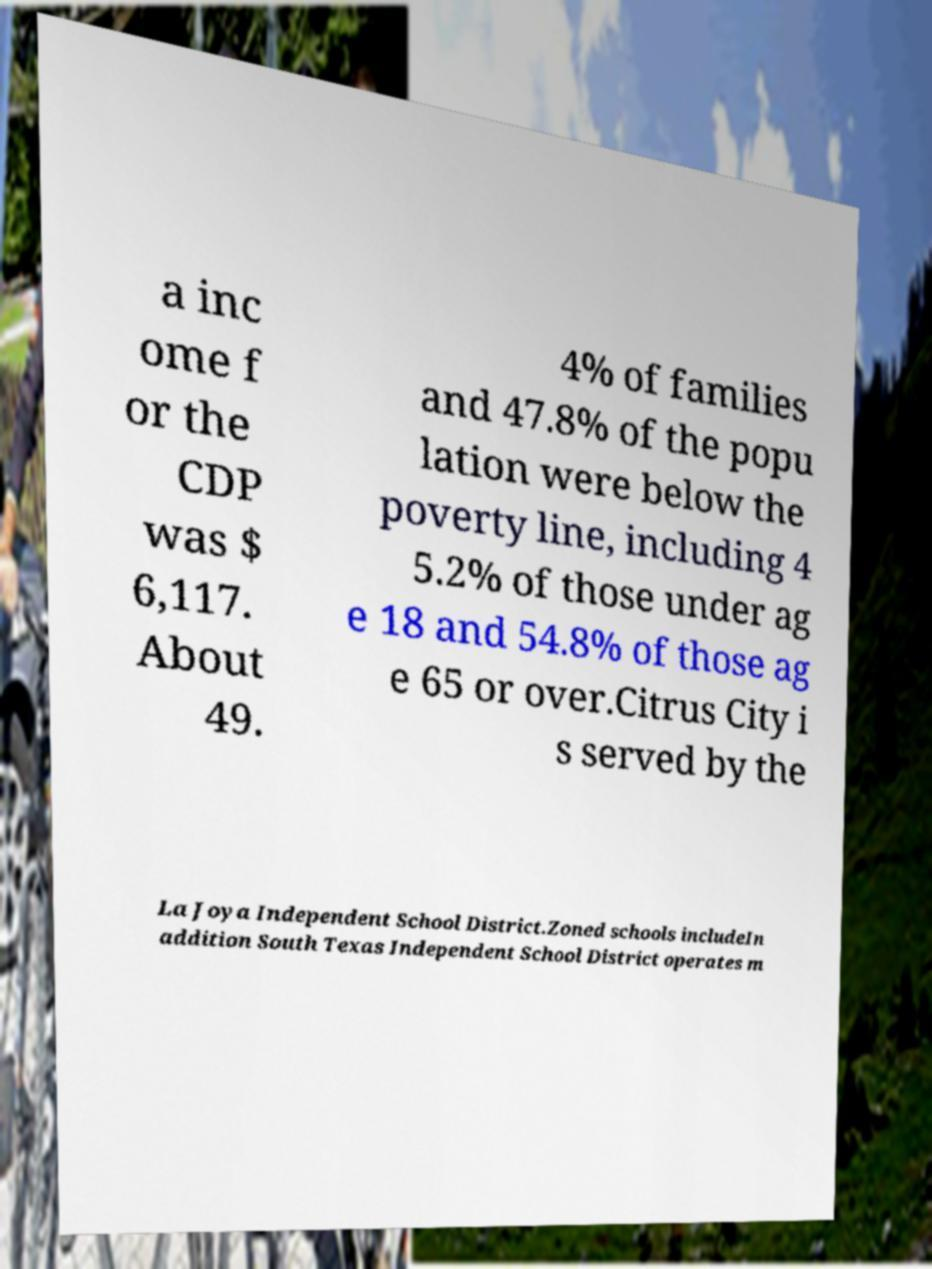Could you assist in decoding the text presented in this image and type it out clearly? a inc ome f or the CDP was $ 6,117. About 49. 4% of families and 47.8% of the popu lation were below the poverty line, including 4 5.2% of those under ag e 18 and 54.8% of those ag e 65 or over.Citrus City i s served by the La Joya Independent School District.Zoned schools includeIn addition South Texas Independent School District operates m 